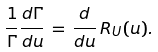Convert formula to latex. <formula><loc_0><loc_0><loc_500><loc_500>\frac { 1 } { \Gamma } \frac { d \Gamma } { d u } \, = \, \frac { d } { d u } \, R _ { U } ( u ) .</formula> 